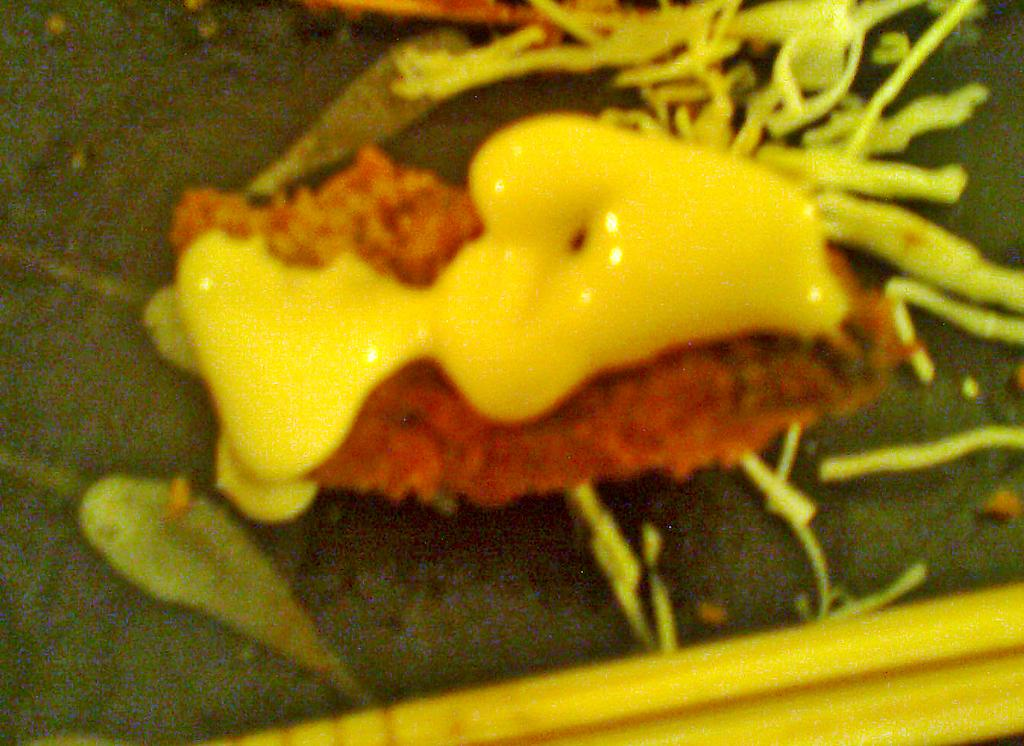What is present in the image? There are food items in the image. What can be inferred about the food items? The food items are on an object. What class is being taught in the image? There is no class or teaching activity present in the image; it only features food items on an object. 